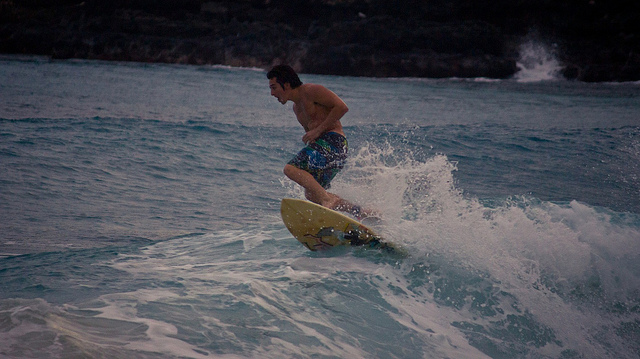<image>What number is on the bottom of the surfboard? I am not sure about the number on the bottom of the surfboard. It could be '13', '0', or '3'. What number is on the bottom of the surfboard? I don't know what number is on the bottom of the surfboard. It can be seen '13', '0', '3' or it might be unknown. 